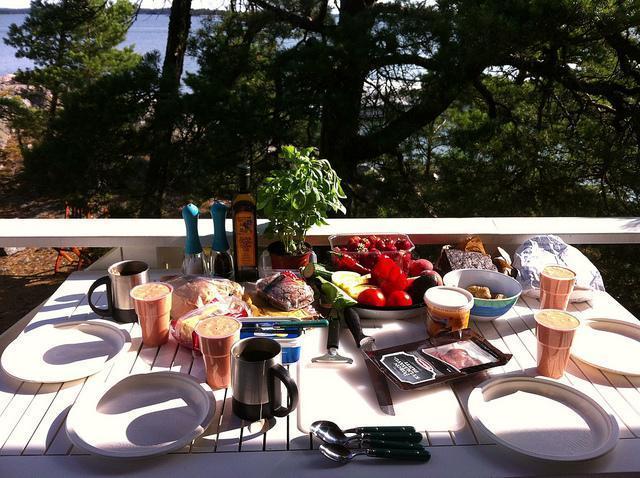How many cups are on the table?
Give a very brief answer. 6. How many cups are there?
Give a very brief answer. 6. How many bowls can be seen?
Give a very brief answer. 2. How many people are shown?
Give a very brief answer. 0. 